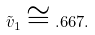<formula> <loc_0><loc_0><loc_500><loc_500>\tilde { v } _ { 1 } \cong . 6 6 7 .</formula> 